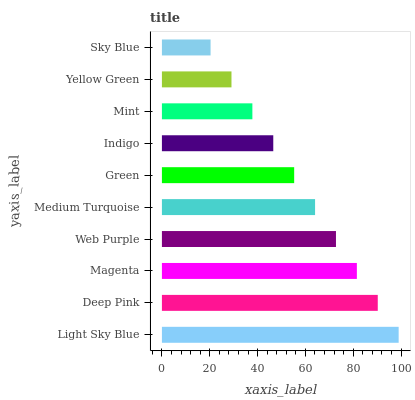Is Sky Blue the minimum?
Answer yes or no. Yes. Is Light Sky Blue the maximum?
Answer yes or no. Yes. Is Deep Pink the minimum?
Answer yes or no. No. Is Deep Pink the maximum?
Answer yes or no. No. Is Light Sky Blue greater than Deep Pink?
Answer yes or no. Yes. Is Deep Pink less than Light Sky Blue?
Answer yes or no. Yes. Is Deep Pink greater than Light Sky Blue?
Answer yes or no. No. Is Light Sky Blue less than Deep Pink?
Answer yes or no. No. Is Medium Turquoise the high median?
Answer yes or no. Yes. Is Green the low median?
Answer yes or no. Yes. Is Green the high median?
Answer yes or no. No. Is Magenta the low median?
Answer yes or no. No. 